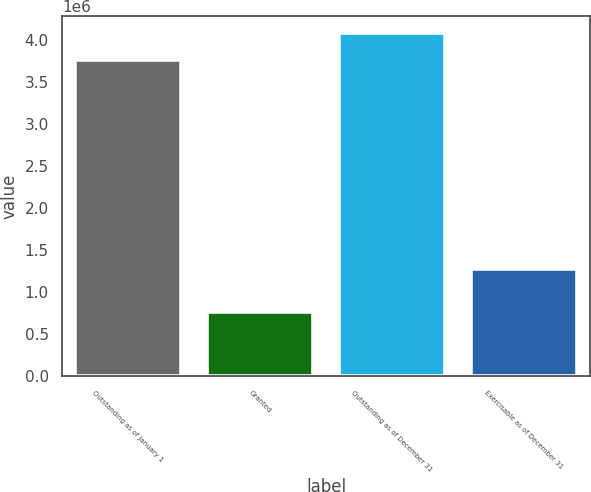Convert chart. <chart><loc_0><loc_0><loc_500><loc_500><bar_chart><fcel>Outstanding as of January 1<fcel>Granted<fcel>Outstanding as of December 31<fcel>Exercisable as of December 31<nl><fcel>3.75795e+06<fcel>764789<fcel>4.07636e+06<fcel>1.2805e+06<nl></chart> 